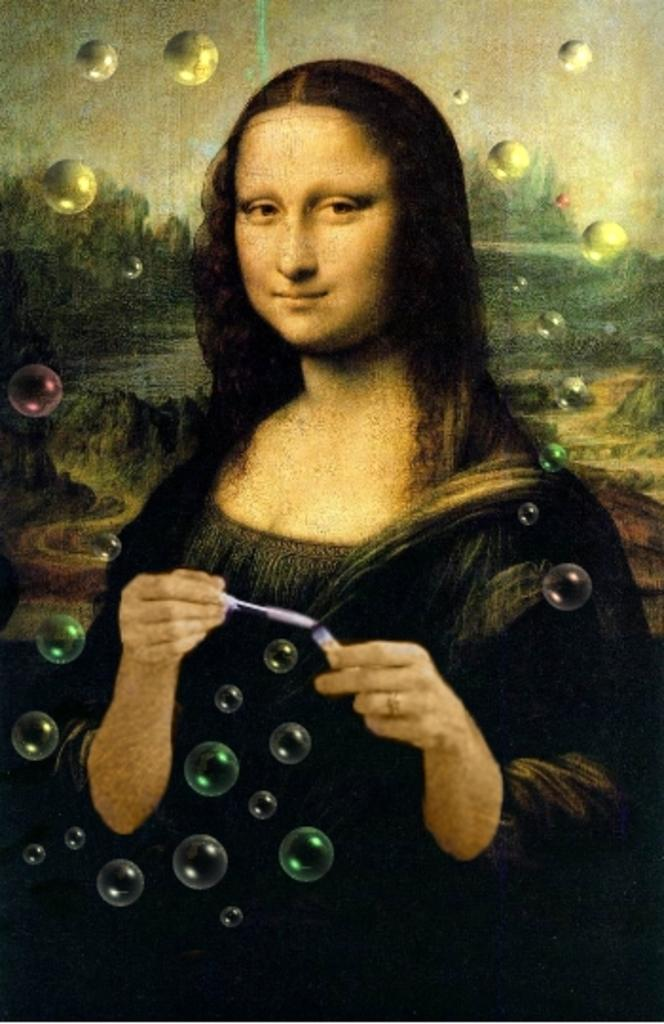What is depicted in the painting in the image? A: There is a painting of a girl in the image. What is in front of the girl in the painting? There are bubbles in front of the girl in the image. What type of pot is visible in the image? There is no pot present in the image. Is the girl depicted in the painting showing any signs of a wound? The image does not provide any information about the girl's physical condition, so it cannot be determined if she has a wound. 